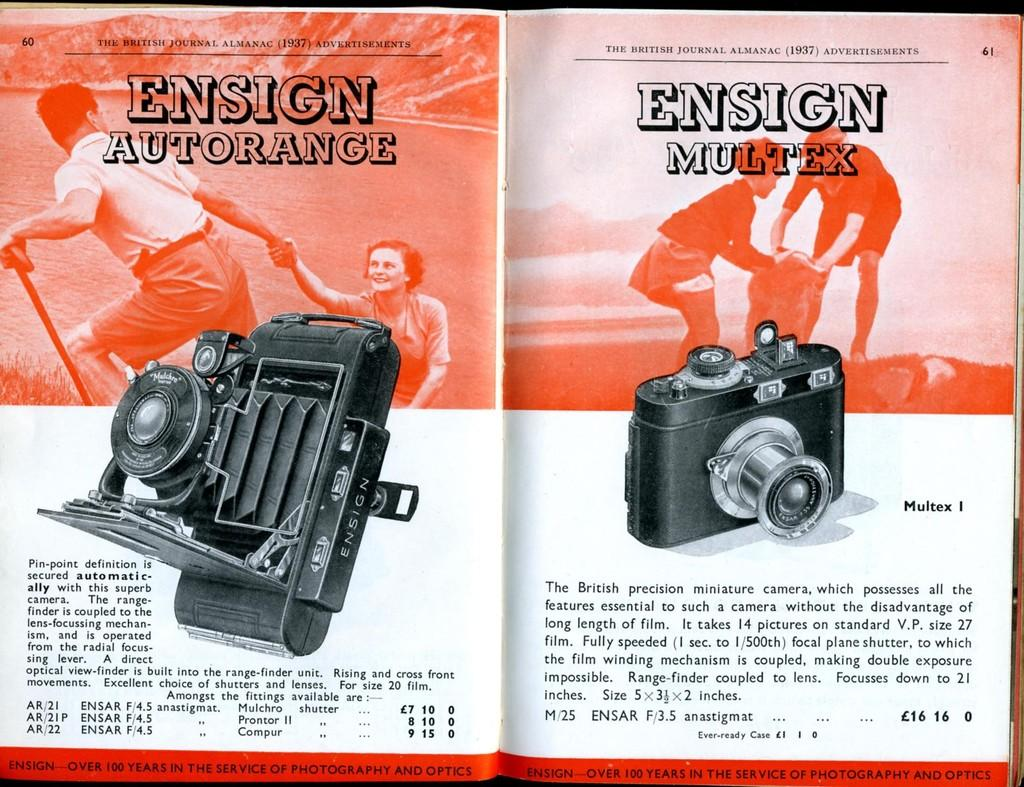What is present on the papers in the image? There are depictions and information on the papers. Can you describe the depictions on the papers? Unfortunately, the specific depictions on the papers cannot be described without more information. What type of information is present on the papers? The information on the papers cannot be determined without more context. What type of oatmeal is being served in the image? There is no oatmeal present in the image; it only features papers with depictions and information. 